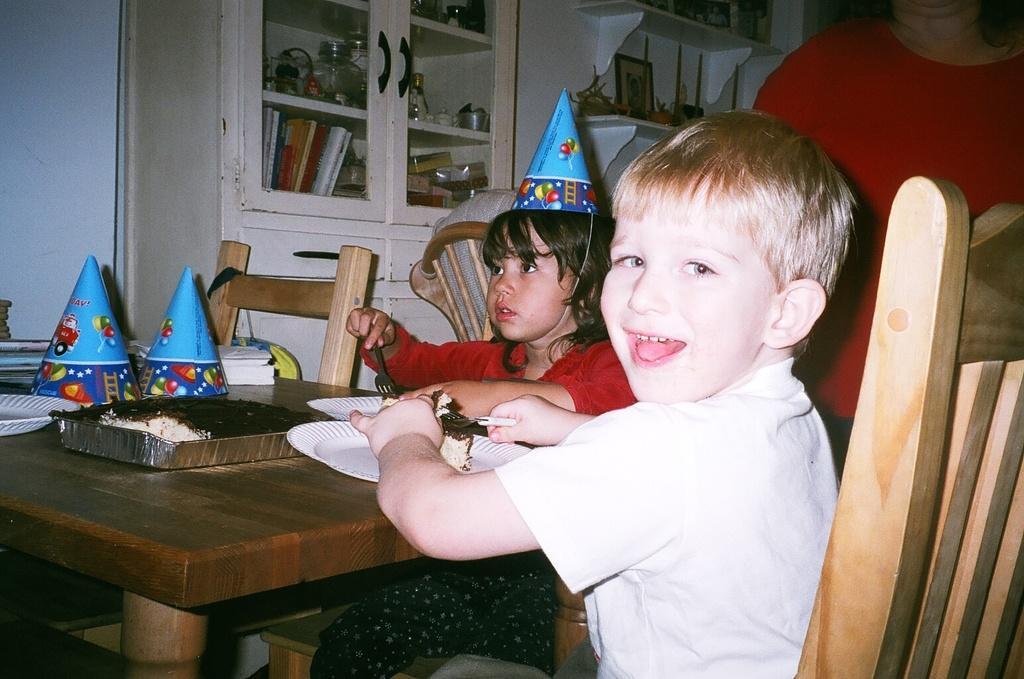Please provide a concise description of this image. In this image I can see two children and they are holding fork. I can also see few plates and few caps over here. i can also see a woman and four chairs. 